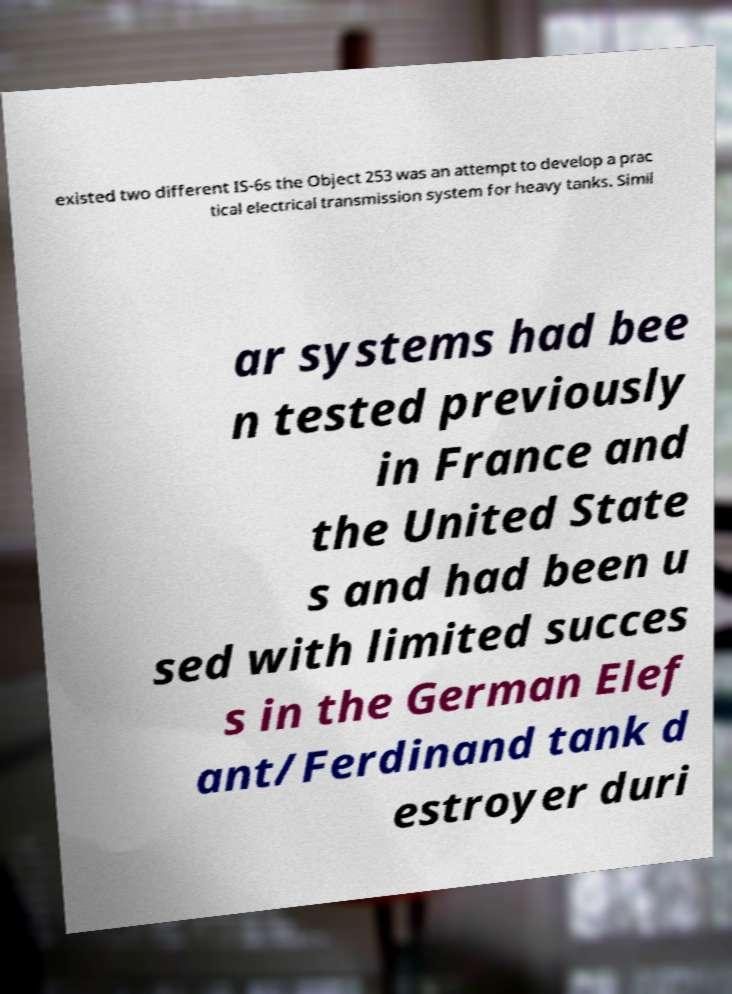I need the written content from this picture converted into text. Can you do that? existed two different IS-6s the Object 253 was an attempt to develop a prac tical electrical transmission system for heavy tanks. Simil ar systems had bee n tested previously in France and the United State s and had been u sed with limited succes s in the German Elef ant/Ferdinand tank d estroyer duri 